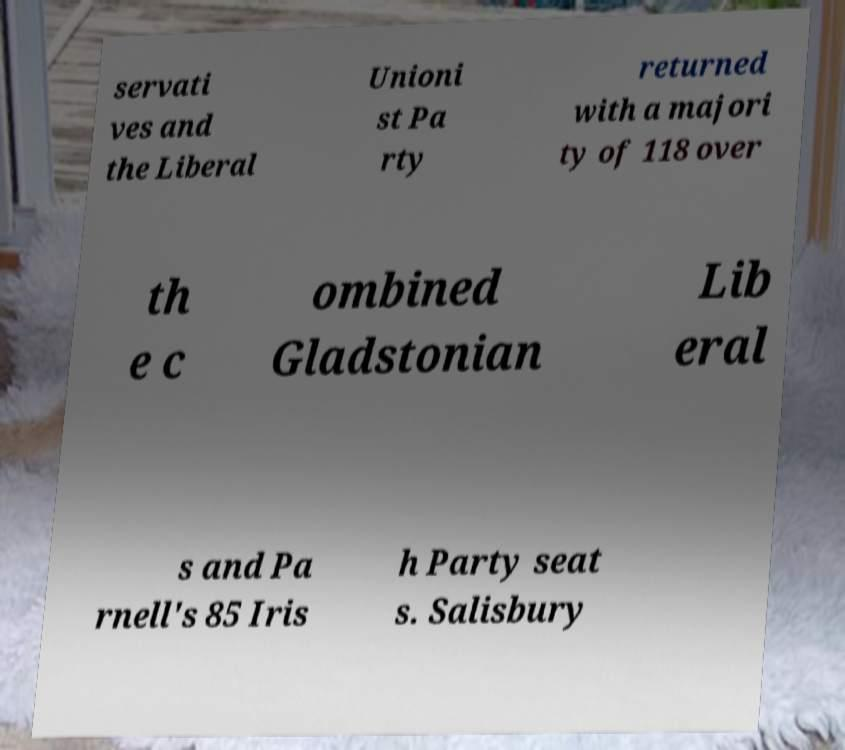Please identify and transcribe the text found in this image. servati ves and the Liberal Unioni st Pa rty returned with a majori ty of 118 over th e c ombined Gladstonian Lib eral s and Pa rnell's 85 Iris h Party seat s. Salisbury 